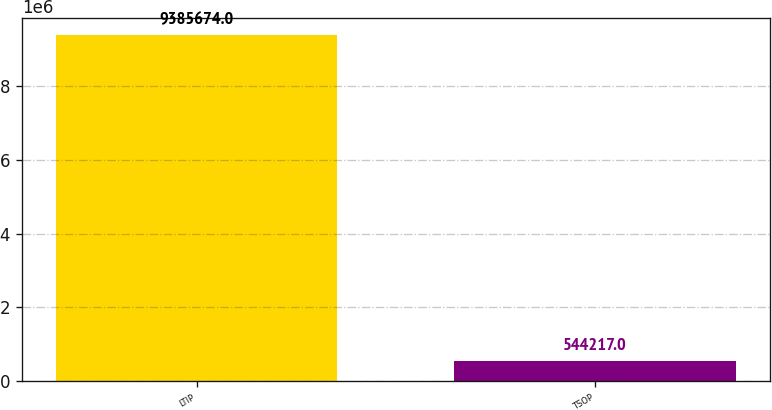Convert chart to OTSL. <chart><loc_0><loc_0><loc_500><loc_500><bar_chart><fcel>LTIP<fcel>TSOP<nl><fcel>9.38567e+06<fcel>544217<nl></chart> 